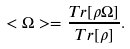<formula> <loc_0><loc_0><loc_500><loc_500>< \Omega > = \frac { T r [ \rho \Omega ] } { T r [ \rho ] } .</formula> 